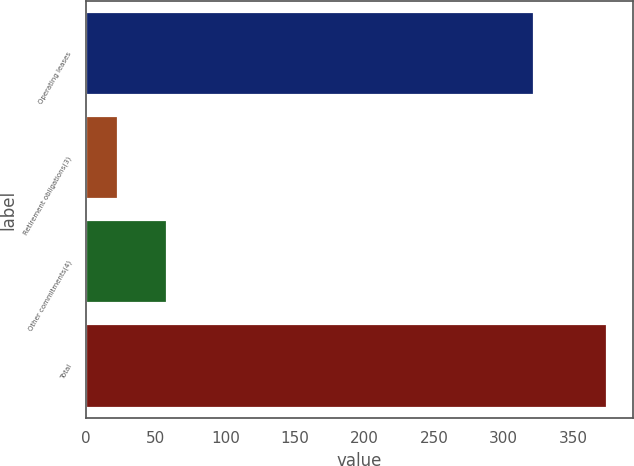<chart> <loc_0><loc_0><loc_500><loc_500><bar_chart><fcel>Operating leases<fcel>Retirement obligations(3)<fcel>Other commitments(4)<fcel>Total<nl><fcel>322<fcel>23<fcel>58.1<fcel>374<nl></chart> 